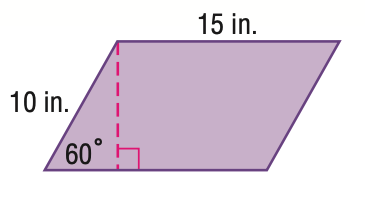Question: Find the area of the figure. Round to the nearest tenth.
Choices:
A. 75
B. 106.1
C. 129.9
D. 259.8
Answer with the letter. Answer: C 